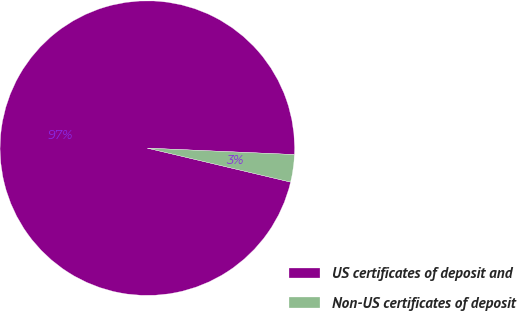Convert chart to OTSL. <chart><loc_0><loc_0><loc_500><loc_500><pie_chart><fcel>US certificates of deposit and<fcel>Non-US certificates of deposit<nl><fcel>96.99%<fcel>3.01%<nl></chart> 